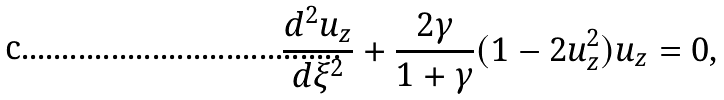<formula> <loc_0><loc_0><loc_500><loc_500>\frac { d ^ { 2 } u _ { z } } { d \xi ^ { 2 } } + \frac { 2 \gamma } { 1 + \gamma } ( 1 - 2 u _ { z } ^ { 2 } ) u _ { z } = 0 ,</formula> 